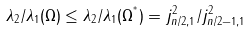<formula> <loc_0><loc_0><loc_500><loc_500>\lambda _ { 2 } / \lambda _ { 1 } ( \Omega ) \leq \lambda _ { 2 } / \lambda _ { 1 } ( \Omega ^ { ^ { * } } ) = j _ { n / 2 , 1 } ^ { 2 } / j _ { n / 2 - 1 , 1 } ^ { 2 }</formula> 